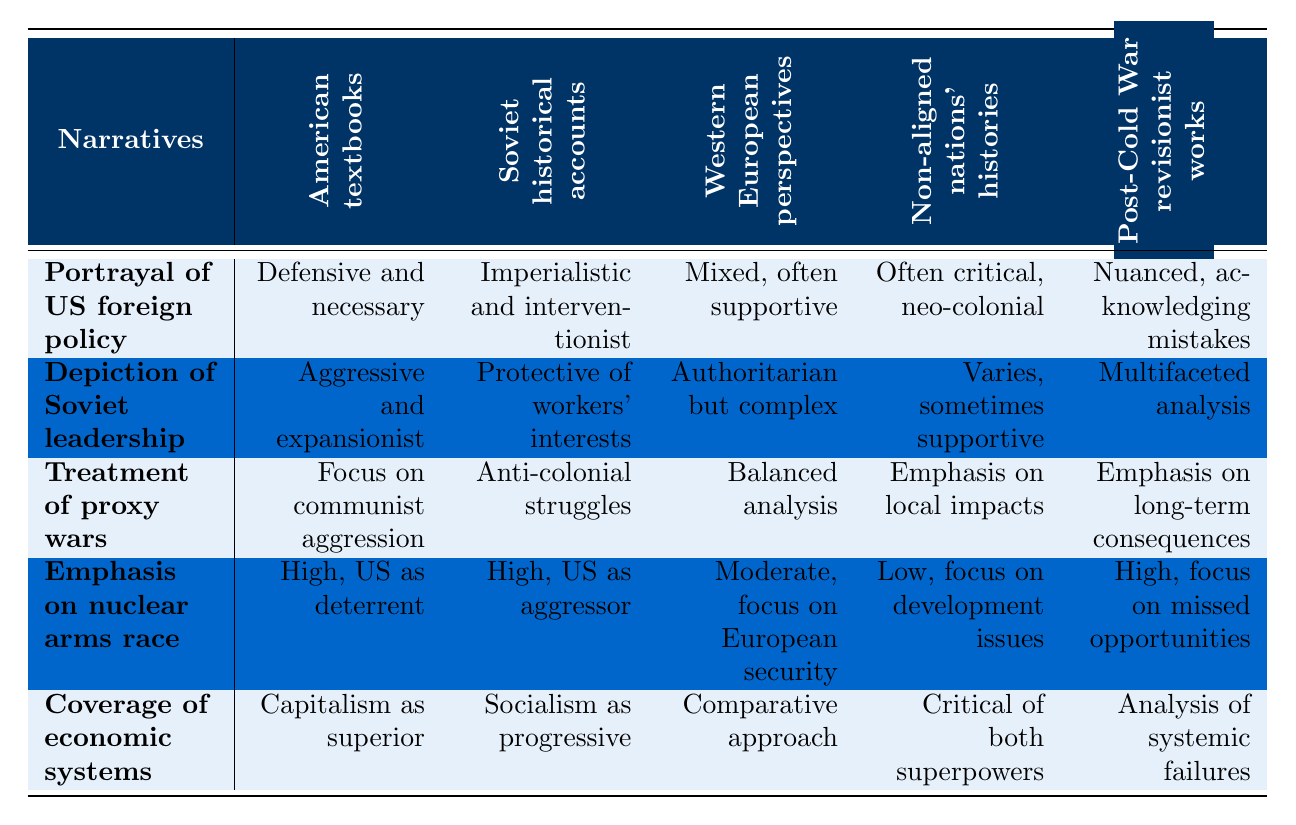What is the portrayal of US foreign policy in Soviet historical accounts? The table shows that the portrayal of US foreign policy in Soviet historical accounts is "Imperialistic and interventionist." This directly reflects the viewpoint expressed in that narrative.
Answer: Imperialistic and interventionist How do Western European perspectives depict Soviet leadership? According to the table, Western European perspectives depict Soviet leadership as "Authoritarian but complex," indicating a nuanced viewpoint rather than a purely negative portrayal.
Answer: Authoritarian but complex Which narrative emphasizes local impacts in the treatment of proxy wars? The table indicates that "Non-aligned nations' histories" emphasizes "local impacts" in the treatment of proxy wars, showcasing a focus on regional consequences rather than a broader geopolitical analysis.
Answer: Non-aligned nations' histories How does the emphasis on the nuclear arms race differ between American textbooks and post-Cold War revisionist works? In American textbooks, the emphasis on the nuclear arms race is "High, US as deterrent," while in post-Cold War revisionist works, it is "High, focus on missed opportunities." This shows that both emphasize the nuclear arms race, but the context and implications differ.
Answer: Both have high emphasis, but with different focuses Is the portrayal of US foreign policy in American textbooks critical? The table shows that the portrayal in American textbooks is "Defensive and necessary," which does not indicate a critical stance. Therefore, the answer is no.
Answer: No Which narrative has a comparative approach in covering economic systems? The table states that "Western European perspectives" use a "Comparative approach" in their coverage of economic systems, indicating that they analyze multiple systems in relation to each other.
Answer: Western European perspectives What are the differing portrayals of Soviet leadership in Soviet historical accounts and post-Cold War revisionist works? Soviet historical accounts depict Soviet leadership as "Protective of workers' interests," whereas post-Cold War revisionist works provide a "Multifaceted analysis," illustrating varied perspectives depending on the narrative context.
Answer: Protective of workers' interests; Multifaceted analysis What is the average portrayal of US foreign policy across all narratives? To find the average depiction, we assign values (e.g., positive, negative) and analyze the overall patterns. Since the portrayals vary greatly, making it difficult to assign a meaningful average without specific scoring criteria leads to a conclusion that there is no distinct average portrayal evident; thus, we can summarize the findings qualitatively as mixed.
Answer: Mixed How do the portrayals of economic systems differ among narratives? The table shows differences: American textbooks favor "Capitalism as superior," Soviet accounts show "Socialism as progressive," Western perspectives take a "Comparative approach," Non-aligned nations are "Critical of both superpowers," and revisionist works analyze "systemic failures." This indicates diverse views on economic systems across the narratives.
Answer: Diverse views across narratives 